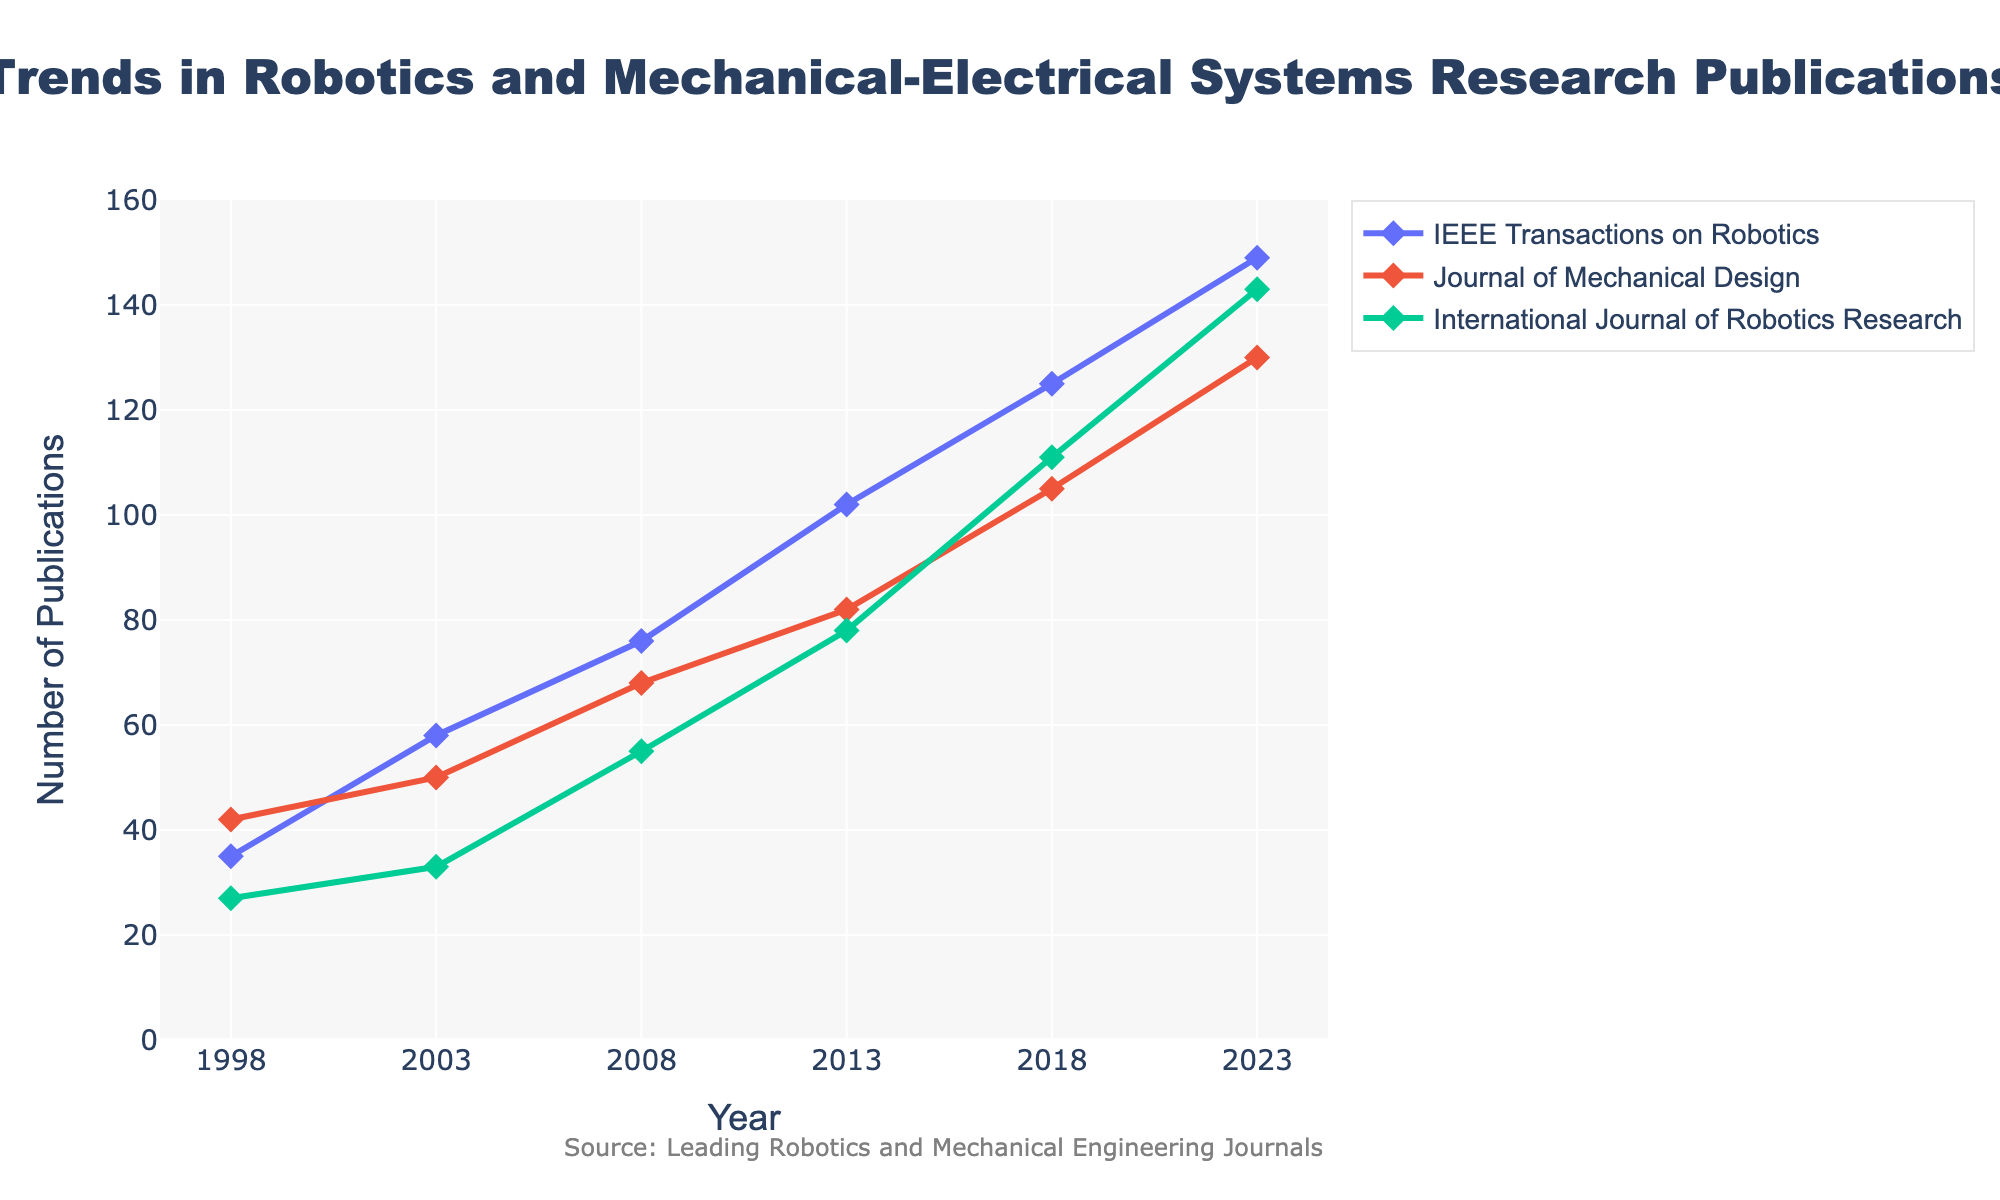What is the title of the figure? The title is the large text displayed at the top center of the figure. It is explicitly given as "Trends in Robotics and Mechanical-Electrical Systems Research Publications".
Answer: Trends in Robotics and Mechanical-Electrical Systems Research Publications How many journals are included in this figure? The figure shows lines with markers for different sets of data. By looking at the legend, we can count that there are three distinct journals represented by differently colored lines/markers.
Answer: Three What is the publication trend for the IEEE Transactions on Robotics from 1998 to 2023? By following the line labeled "IEEE Transactions on Robotics", we can see that the number of publications increased steadily over the years. Starting at 35 in 1998, it rises to 149 in 2023.
Answer: Increasing Which journal had the highest number of publications in 2018? By locating the year 2018 on the x-axis and comparing the y-values of the lines representing each journal, we see that the 'International Journal of Robotics Research' had the highest number, with 111 publications.
Answer: International Journal of Robotics Research What is the total number of publications for Journal of Mechanical Design in the years provided? Summing the figures for the 'Journal of Mechanical Design' from the years (42 in 1998, 50 in 2003, 68 in 2008, 82 in 2013, 105 in 2018, 130 in 2023) gives a total: 42 + 50 + 68 + 82 + 105 + 130 = 477.
Answer: 477 In which year did IEEE Transactions on Robotics see the largest increase in publications compared to the previous datapoint? To find the largest increase, we compute the differences between consecutive years: 58-35 = 23 (2003-1998), 76-58 = 18 (2008-2003), 102-76 = 26 (2013-2008), 125-102 = 23 (2018-2013), 149-125 = 24 (2023-2018). The largest increase is 26, occurring between 2008 and 2013.
Answer: 2013 Compare the trends for IEEE Transactions on Robotics and International Journal of Robotics Research. Which journal shows a steeper increase over the 25 years? By observing the slopes of the lines for IEEE Transactions on Robotics and International Journal of Robotics Research, IEEE Transactions on Robotics starts at 35 and ends at 149, while International Journal of Robotics Research starts at 27 and ends at 143. The steeper increase is in IEEE Transactions on Robotics (ΔY = 114 vs. 116 over 25 years).
Answer: About the same What is the average number of publications for the International Journal of Robotics Research from the years provided? Averaging the values for the International Journal of Robotics Research: (27 + 33 + 55 + 78 + 111 + 143) / 6 = 447 / 6 ≈ 74.5
Answer: 74.5 Are there any years in which all three journals had exactly the same number of publications? By checking the y-values for all three journals for each year on the x-axis, we observe that there is no year where all three journals have the exact same number of publications.
Answer: No 